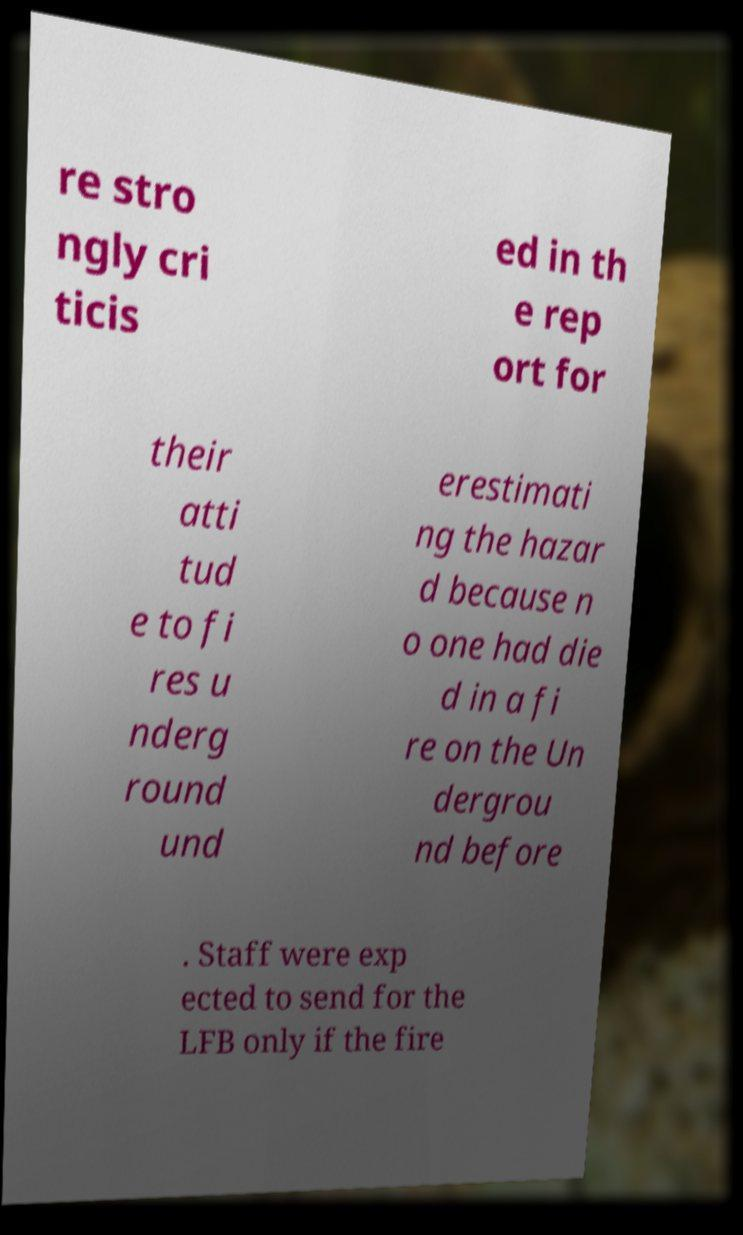Can you accurately transcribe the text from the provided image for me? re stro ngly cri ticis ed in th e rep ort for their atti tud e to fi res u nderg round und erestimati ng the hazar d because n o one had die d in a fi re on the Un dergrou nd before . Staff were exp ected to send for the LFB only if the fire 